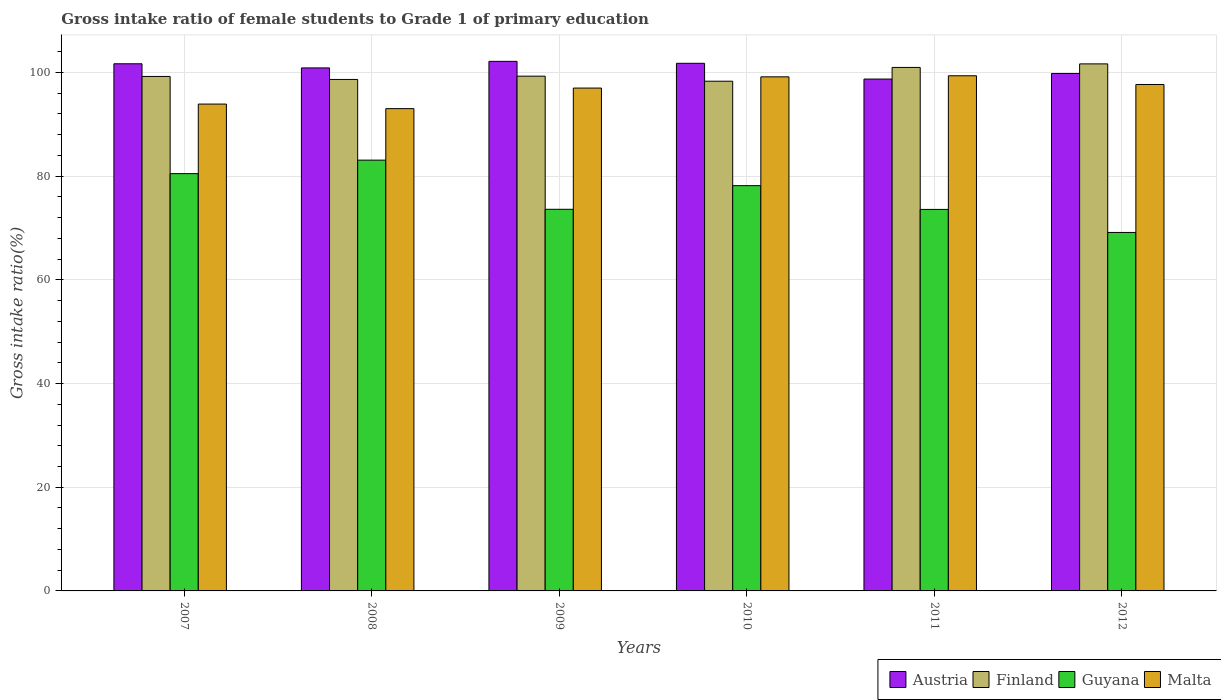Are the number of bars on each tick of the X-axis equal?
Keep it short and to the point. Yes. How many bars are there on the 5th tick from the right?
Your answer should be compact. 4. What is the label of the 6th group of bars from the left?
Ensure brevity in your answer.  2012. In how many cases, is the number of bars for a given year not equal to the number of legend labels?
Your answer should be compact. 0. What is the gross intake ratio in Austria in 2008?
Provide a succinct answer. 100.88. Across all years, what is the maximum gross intake ratio in Guyana?
Your answer should be compact. 83.1. Across all years, what is the minimum gross intake ratio in Guyana?
Your response must be concise. 69.15. In which year was the gross intake ratio in Austria maximum?
Your response must be concise. 2009. In which year was the gross intake ratio in Finland minimum?
Your answer should be very brief. 2010. What is the total gross intake ratio in Malta in the graph?
Offer a terse response. 580.16. What is the difference between the gross intake ratio in Guyana in 2007 and that in 2008?
Provide a succinct answer. -2.61. What is the difference between the gross intake ratio in Guyana in 2011 and the gross intake ratio in Austria in 2008?
Your response must be concise. -27.29. What is the average gross intake ratio in Austria per year?
Ensure brevity in your answer.  100.84. In the year 2007, what is the difference between the gross intake ratio in Malta and gross intake ratio in Finland?
Your answer should be compact. -5.33. In how many years, is the gross intake ratio in Guyana greater than 88 %?
Your answer should be compact. 0. What is the ratio of the gross intake ratio in Finland in 2010 to that in 2012?
Offer a terse response. 0.97. Is the difference between the gross intake ratio in Malta in 2007 and 2011 greater than the difference between the gross intake ratio in Finland in 2007 and 2011?
Keep it short and to the point. No. What is the difference between the highest and the second highest gross intake ratio in Finland?
Keep it short and to the point. 0.68. What is the difference between the highest and the lowest gross intake ratio in Finland?
Provide a succinct answer. 3.34. Is the sum of the gross intake ratio in Guyana in 2008 and 2010 greater than the maximum gross intake ratio in Malta across all years?
Your answer should be compact. Yes. Is it the case that in every year, the sum of the gross intake ratio in Guyana and gross intake ratio in Austria is greater than the sum of gross intake ratio in Finland and gross intake ratio in Malta?
Offer a very short reply. No. What does the 4th bar from the left in 2010 represents?
Offer a very short reply. Malta. What does the 4th bar from the right in 2007 represents?
Offer a very short reply. Austria. How many bars are there?
Your answer should be very brief. 24. Does the graph contain any zero values?
Give a very brief answer. No. Where does the legend appear in the graph?
Offer a very short reply. Bottom right. What is the title of the graph?
Your answer should be very brief. Gross intake ratio of female students to Grade 1 of primary education. What is the label or title of the Y-axis?
Give a very brief answer. Gross intake ratio(%). What is the Gross intake ratio(%) in Austria in 2007?
Provide a succinct answer. 101.68. What is the Gross intake ratio(%) in Finland in 2007?
Provide a short and direct response. 99.24. What is the Gross intake ratio(%) of Guyana in 2007?
Provide a short and direct response. 80.49. What is the Gross intake ratio(%) of Malta in 2007?
Provide a succinct answer. 93.91. What is the Gross intake ratio(%) in Austria in 2008?
Offer a very short reply. 100.88. What is the Gross intake ratio(%) in Finland in 2008?
Provide a short and direct response. 98.66. What is the Gross intake ratio(%) in Guyana in 2008?
Offer a terse response. 83.1. What is the Gross intake ratio(%) in Malta in 2008?
Provide a succinct answer. 93.03. What is the Gross intake ratio(%) of Austria in 2009?
Your response must be concise. 102.15. What is the Gross intake ratio(%) in Finland in 2009?
Make the answer very short. 99.3. What is the Gross intake ratio(%) in Guyana in 2009?
Provide a succinct answer. 73.61. What is the Gross intake ratio(%) in Malta in 2009?
Your response must be concise. 97. What is the Gross intake ratio(%) in Austria in 2010?
Provide a succinct answer. 101.78. What is the Gross intake ratio(%) of Finland in 2010?
Your answer should be compact. 98.32. What is the Gross intake ratio(%) in Guyana in 2010?
Offer a terse response. 78.17. What is the Gross intake ratio(%) in Malta in 2010?
Offer a very short reply. 99.16. What is the Gross intake ratio(%) of Austria in 2011?
Keep it short and to the point. 98.74. What is the Gross intake ratio(%) of Finland in 2011?
Ensure brevity in your answer.  100.98. What is the Gross intake ratio(%) of Guyana in 2011?
Make the answer very short. 73.59. What is the Gross intake ratio(%) of Malta in 2011?
Ensure brevity in your answer.  99.37. What is the Gross intake ratio(%) of Austria in 2012?
Give a very brief answer. 99.81. What is the Gross intake ratio(%) in Finland in 2012?
Offer a very short reply. 101.66. What is the Gross intake ratio(%) in Guyana in 2012?
Give a very brief answer. 69.15. What is the Gross intake ratio(%) in Malta in 2012?
Keep it short and to the point. 97.69. Across all years, what is the maximum Gross intake ratio(%) in Austria?
Offer a very short reply. 102.15. Across all years, what is the maximum Gross intake ratio(%) of Finland?
Your response must be concise. 101.66. Across all years, what is the maximum Gross intake ratio(%) of Guyana?
Your answer should be very brief. 83.1. Across all years, what is the maximum Gross intake ratio(%) in Malta?
Your answer should be very brief. 99.37. Across all years, what is the minimum Gross intake ratio(%) in Austria?
Provide a short and direct response. 98.74. Across all years, what is the minimum Gross intake ratio(%) of Finland?
Give a very brief answer. 98.32. Across all years, what is the minimum Gross intake ratio(%) in Guyana?
Ensure brevity in your answer.  69.15. Across all years, what is the minimum Gross intake ratio(%) in Malta?
Provide a succinct answer. 93.03. What is the total Gross intake ratio(%) in Austria in the graph?
Make the answer very short. 605.04. What is the total Gross intake ratio(%) in Finland in the graph?
Make the answer very short. 598.16. What is the total Gross intake ratio(%) of Guyana in the graph?
Your answer should be very brief. 458.12. What is the total Gross intake ratio(%) of Malta in the graph?
Ensure brevity in your answer.  580.16. What is the difference between the Gross intake ratio(%) of Austria in 2007 and that in 2008?
Provide a succinct answer. 0.8. What is the difference between the Gross intake ratio(%) of Finland in 2007 and that in 2008?
Provide a succinct answer. 0.58. What is the difference between the Gross intake ratio(%) in Guyana in 2007 and that in 2008?
Provide a short and direct response. -2.61. What is the difference between the Gross intake ratio(%) in Malta in 2007 and that in 2008?
Your answer should be very brief. 0.88. What is the difference between the Gross intake ratio(%) of Austria in 2007 and that in 2009?
Your answer should be very brief. -0.47. What is the difference between the Gross intake ratio(%) in Finland in 2007 and that in 2009?
Make the answer very short. -0.06. What is the difference between the Gross intake ratio(%) of Guyana in 2007 and that in 2009?
Give a very brief answer. 6.88. What is the difference between the Gross intake ratio(%) of Malta in 2007 and that in 2009?
Your answer should be compact. -3.09. What is the difference between the Gross intake ratio(%) of Austria in 2007 and that in 2010?
Your answer should be compact. -0.09. What is the difference between the Gross intake ratio(%) of Finland in 2007 and that in 2010?
Provide a short and direct response. 0.92. What is the difference between the Gross intake ratio(%) in Guyana in 2007 and that in 2010?
Offer a terse response. 2.32. What is the difference between the Gross intake ratio(%) of Malta in 2007 and that in 2010?
Offer a very short reply. -5.25. What is the difference between the Gross intake ratio(%) of Austria in 2007 and that in 2011?
Offer a terse response. 2.95. What is the difference between the Gross intake ratio(%) of Finland in 2007 and that in 2011?
Keep it short and to the point. -1.74. What is the difference between the Gross intake ratio(%) of Guyana in 2007 and that in 2011?
Your answer should be very brief. 6.9. What is the difference between the Gross intake ratio(%) in Malta in 2007 and that in 2011?
Your answer should be compact. -5.46. What is the difference between the Gross intake ratio(%) of Austria in 2007 and that in 2012?
Your answer should be very brief. 1.88. What is the difference between the Gross intake ratio(%) in Finland in 2007 and that in 2012?
Your response must be concise. -2.42. What is the difference between the Gross intake ratio(%) in Guyana in 2007 and that in 2012?
Give a very brief answer. 11.34. What is the difference between the Gross intake ratio(%) in Malta in 2007 and that in 2012?
Your response must be concise. -3.77. What is the difference between the Gross intake ratio(%) of Austria in 2008 and that in 2009?
Offer a very short reply. -1.27. What is the difference between the Gross intake ratio(%) of Finland in 2008 and that in 2009?
Your answer should be very brief. -0.63. What is the difference between the Gross intake ratio(%) in Guyana in 2008 and that in 2009?
Your answer should be compact. 9.48. What is the difference between the Gross intake ratio(%) of Malta in 2008 and that in 2009?
Provide a short and direct response. -3.97. What is the difference between the Gross intake ratio(%) in Austria in 2008 and that in 2010?
Offer a terse response. -0.89. What is the difference between the Gross intake ratio(%) in Finland in 2008 and that in 2010?
Ensure brevity in your answer.  0.34. What is the difference between the Gross intake ratio(%) of Guyana in 2008 and that in 2010?
Provide a succinct answer. 4.92. What is the difference between the Gross intake ratio(%) in Malta in 2008 and that in 2010?
Provide a short and direct response. -6.13. What is the difference between the Gross intake ratio(%) of Austria in 2008 and that in 2011?
Keep it short and to the point. 2.15. What is the difference between the Gross intake ratio(%) of Finland in 2008 and that in 2011?
Your answer should be compact. -2.32. What is the difference between the Gross intake ratio(%) in Guyana in 2008 and that in 2011?
Keep it short and to the point. 9.51. What is the difference between the Gross intake ratio(%) in Malta in 2008 and that in 2011?
Provide a succinct answer. -6.34. What is the difference between the Gross intake ratio(%) in Austria in 2008 and that in 2012?
Provide a short and direct response. 1.08. What is the difference between the Gross intake ratio(%) in Finland in 2008 and that in 2012?
Your answer should be very brief. -3. What is the difference between the Gross intake ratio(%) of Guyana in 2008 and that in 2012?
Give a very brief answer. 13.95. What is the difference between the Gross intake ratio(%) in Malta in 2008 and that in 2012?
Your answer should be very brief. -4.65. What is the difference between the Gross intake ratio(%) of Austria in 2009 and that in 2010?
Give a very brief answer. 0.38. What is the difference between the Gross intake ratio(%) of Finland in 2009 and that in 2010?
Ensure brevity in your answer.  0.97. What is the difference between the Gross intake ratio(%) of Guyana in 2009 and that in 2010?
Keep it short and to the point. -4.56. What is the difference between the Gross intake ratio(%) in Malta in 2009 and that in 2010?
Give a very brief answer. -2.17. What is the difference between the Gross intake ratio(%) of Austria in 2009 and that in 2011?
Your answer should be compact. 3.41. What is the difference between the Gross intake ratio(%) in Finland in 2009 and that in 2011?
Offer a terse response. -1.68. What is the difference between the Gross intake ratio(%) in Guyana in 2009 and that in 2011?
Your response must be concise. 0.02. What is the difference between the Gross intake ratio(%) in Malta in 2009 and that in 2011?
Your answer should be compact. -2.37. What is the difference between the Gross intake ratio(%) of Austria in 2009 and that in 2012?
Give a very brief answer. 2.34. What is the difference between the Gross intake ratio(%) of Finland in 2009 and that in 2012?
Provide a succinct answer. -2.37. What is the difference between the Gross intake ratio(%) in Guyana in 2009 and that in 2012?
Your answer should be very brief. 4.47. What is the difference between the Gross intake ratio(%) of Malta in 2009 and that in 2012?
Give a very brief answer. -0.69. What is the difference between the Gross intake ratio(%) of Austria in 2010 and that in 2011?
Offer a terse response. 3.04. What is the difference between the Gross intake ratio(%) in Finland in 2010 and that in 2011?
Give a very brief answer. -2.66. What is the difference between the Gross intake ratio(%) in Guyana in 2010 and that in 2011?
Your answer should be compact. 4.58. What is the difference between the Gross intake ratio(%) of Malta in 2010 and that in 2011?
Your answer should be very brief. -0.2. What is the difference between the Gross intake ratio(%) in Austria in 2010 and that in 2012?
Offer a very short reply. 1.97. What is the difference between the Gross intake ratio(%) of Finland in 2010 and that in 2012?
Provide a succinct answer. -3.34. What is the difference between the Gross intake ratio(%) in Guyana in 2010 and that in 2012?
Offer a very short reply. 9.03. What is the difference between the Gross intake ratio(%) of Malta in 2010 and that in 2012?
Keep it short and to the point. 1.48. What is the difference between the Gross intake ratio(%) of Austria in 2011 and that in 2012?
Provide a succinct answer. -1.07. What is the difference between the Gross intake ratio(%) of Finland in 2011 and that in 2012?
Offer a terse response. -0.68. What is the difference between the Gross intake ratio(%) in Guyana in 2011 and that in 2012?
Your response must be concise. 4.44. What is the difference between the Gross intake ratio(%) of Malta in 2011 and that in 2012?
Make the answer very short. 1.68. What is the difference between the Gross intake ratio(%) in Austria in 2007 and the Gross intake ratio(%) in Finland in 2008?
Your response must be concise. 3.02. What is the difference between the Gross intake ratio(%) in Austria in 2007 and the Gross intake ratio(%) in Guyana in 2008?
Your response must be concise. 18.59. What is the difference between the Gross intake ratio(%) in Austria in 2007 and the Gross intake ratio(%) in Malta in 2008?
Give a very brief answer. 8.65. What is the difference between the Gross intake ratio(%) in Finland in 2007 and the Gross intake ratio(%) in Guyana in 2008?
Your answer should be very brief. 16.14. What is the difference between the Gross intake ratio(%) of Finland in 2007 and the Gross intake ratio(%) of Malta in 2008?
Make the answer very short. 6.21. What is the difference between the Gross intake ratio(%) of Guyana in 2007 and the Gross intake ratio(%) of Malta in 2008?
Your response must be concise. -12.54. What is the difference between the Gross intake ratio(%) of Austria in 2007 and the Gross intake ratio(%) of Finland in 2009?
Keep it short and to the point. 2.39. What is the difference between the Gross intake ratio(%) in Austria in 2007 and the Gross intake ratio(%) in Guyana in 2009?
Keep it short and to the point. 28.07. What is the difference between the Gross intake ratio(%) of Austria in 2007 and the Gross intake ratio(%) of Malta in 2009?
Offer a terse response. 4.69. What is the difference between the Gross intake ratio(%) in Finland in 2007 and the Gross intake ratio(%) in Guyana in 2009?
Keep it short and to the point. 25.63. What is the difference between the Gross intake ratio(%) in Finland in 2007 and the Gross intake ratio(%) in Malta in 2009?
Give a very brief answer. 2.24. What is the difference between the Gross intake ratio(%) of Guyana in 2007 and the Gross intake ratio(%) of Malta in 2009?
Provide a succinct answer. -16.51. What is the difference between the Gross intake ratio(%) of Austria in 2007 and the Gross intake ratio(%) of Finland in 2010?
Provide a succinct answer. 3.36. What is the difference between the Gross intake ratio(%) in Austria in 2007 and the Gross intake ratio(%) in Guyana in 2010?
Your answer should be very brief. 23.51. What is the difference between the Gross intake ratio(%) in Austria in 2007 and the Gross intake ratio(%) in Malta in 2010?
Your answer should be very brief. 2.52. What is the difference between the Gross intake ratio(%) in Finland in 2007 and the Gross intake ratio(%) in Guyana in 2010?
Ensure brevity in your answer.  21.07. What is the difference between the Gross intake ratio(%) in Finland in 2007 and the Gross intake ratio(%) in Malta in 2010?
Give a very brief answer. 0.08. What is the difference between the Gross intake ratio(%) of Guyana in 2007 and the Gross intake ratio(%) of Malta in 2010?
Offer a terse response. -18.67. What is the difference between the Gross intake ratio(%) in Austria in 2007 and the Gross intake ratio(%) in Finland in 2011?
Your response must be concise. 0.7. What is the difference between the Gross intake ratio(%) in Austria in 2007 and the Gross intake ratio(%) in Guyana in 2011?
Your response must be concise. 28.09. What is the difference between the Gross intake ratio(%) in Austria in 2007 and the Gross intake ratio(%) in Malta in 2011?
Make the answer very short. 2.32. What is the difference between the Gross intake ratio(%) of Finland in 2007 and the Gross intake ratio(%) of Guyana in 2011?
Provide a short and direct response. 25.65. What is the difference between the Gross intake ratio(%) in Finland in 2007 and the Gross intake ratio(%) in Malta in 2011?
Offer a terse response. -0.13. What is the difference between the Gross intake ratio(%) of Guyana in 2007 and the Gross intake ratio(%) of Malta in 2011?
Your answer should be compact. -18.88. What is the difference between the Gross intake ratio(%) of Austria in 2007 and the Gross intake ratio(%) of Finland in 2012?
Provide a succinct answer. 0.02. What is the difference between the Gross intake ratio(%) of Austria in 2007 and the Gross intake ratio(%) of Guyana in 2012?
Provide a short and direct response. 32.54. What is the difference between the Gross intake ratio(%) in Austria in 2007 and the Gross intake ratio(%) in Malta in 2012?
Make the answer very short. 4. What is the difference between the Gross intake ratio(%) in Finland in 2007 and the Gross intake ratio(%) in Guyana in 2012?
Provide a short and direct response. 30.09. What is the difference between the Gross intake ratio(%) in Finland in 2007 and the Gross intake ratio(%) in Malta in 2012?
Your answer should be very brief. 1.55. What is the difference between the Gross intake ratio(%) in Guyana in 2007 and the Gross intake ratio(%) in Malta in 2012?
Your response must be concise. -17.19. What is the difference between the Gross intake ratio(%) of Austria in 2008 and the Gross intake ratio(%) of Finland in 2009?
Offer a very short reply. 1.59. What is the difference between the Gross intake ratio(%) in Austria in 2008 and the Gross intake ratio(%) in Guyana in 2009?
Offer a terse response. 27.27. What is the difference between the Gross intake ratio(%) in Austria in 2008 and the Gross intake ratio(%) in Malta in 2009?
Provide a succinct answer. 3.89. What is the difference between the Gross intake ratio(%) in Finland in 2008 and the Gross intake ratio(%) in Guyana in 2009?
Your answer should be very brief. 25.05. What is the difference between the Gross intake ratio(%) of Finland in 2008 and the Gross intake ratio(%) of Malta in 2009?
Offer a very short reply. 1.66. What is the difference between the Gross intake ratio(%) in Guyana in 2008 and the Gross intake ratio(%) in Malta in 2009?
Your response must be concise. -13.9. What is the difference between the Gross intake ratio(%) of Austria in 2008 and the Gross intake ratio(%) of Finland in 2010?
Your response must be concise. 2.56. What is the difference between the Gross intake ratio(%) of Austria in 2008 and the Gross intake ratio(%) of Guyana in 2010?
Your answer should be very brief. 22.71. What is the difference between the Gross intake ratio(%) in Austria in 2008 and the Gross intake ratio(%) in Malta in 2010?
Give a very brief answer. 1.72. What is the difference between the Gross intake ratio(%) of Finland in 2008 and the Gross intake ratio(%) of Guyana in 2010?
Keep it short and to the point. 20.49. What is the difference between the Gross intake ratio(%) in Finland in 2008 and the Gross intake ratio(%) in Malta in 2010?
Your answer should be compact. -0.5. What is the difference between the Gross intake ratio(%) of Guyana in 2008 and the Gross intake ratio(%) of Malta in 2010?
Ensure brevity in your answer.  -16.07. What is the difference between the Gross intake ratio(%) in Austria in 2008 and the Gross intake ratio(%) in Finland in 2011?
Your response must be concise. -0.09. What is the difference between the Gross intake ratio(%) of Austria in 2008 and the Gross intake ratio(%) of Guyana in 2011?
Provide a short and direct response. 27.29. What is the difference between the Gross intake ratio(%) of Austria in 2008 and the Gross intake ratio(%) of Malta in 2011?
Your answer should be very brief. 1.52. What is the difference between the Gross intake ratio(%) of Finland in 2008 and the Gross intake ratio(%) of Guyana in 2011?
Your answer should be very brief. 25.07. What is the difference between the Gross intake ratio(%) in Finland in 2008 and the Gross intake ratio(%) in Malta in 2011?
Offer a terse response. -0.71. What is the difference between the Gross intake ratio(%) of Guyana in 2008 and the Gross intake ratio(%) of Malta in 2011?
Your answer should be compact. -16.27. What is the difference between the Gross intake ratio(%) in Austria in 2008 and the Gross intake ratio(%) in Finland in 2012?
Your answer should be compact. -0.78. What is the difference between the Gross intake ratio(%) of Austria in 2008 and the Gross intake ratio(%) of Guyana in 2012?
Offer a terse response. 31.74. What is the difference between the Gross intake ratio(%) of Austria in 2008 and the Gross intake ratio(%) of Malta in 2012?
Ensure brevity in your answer.  3.2. What is the difference between the Gross intake ratio(%) of Finland in 2008 and the Gross intake ratio(%) of Guyana in 2012?
Your answer should be very brief. 29.51. What is the difference between the Gross intake ratio(%) of Finland in 2008 and the Gross intake ratio(%) of Malta in 2012?
Provide a short and direct response. 0.98. What is the difference between the Gross intake ratio(%) of Guyana in 2008 and the Gross intake ratio(%) of Malta in 2012?
Your answer should be very brief. -14.59. What is the difference between the Gross intake ratio(%) of Austria in 2009 and the Gross intake ratio(%) of Finland in 2010?
Give a very brief answer. 3.83. What is the difference between the Gross intake ratio(%) in Austria in 2009 and the Gross intake ratio(%) in Guyana in 2010?
Your answer should be very brief. 23.98. What is the difference between the Gross intake ratio(%) of Austria in 2009 and the Gross intake ratio(%) of Malta in 2010?
Your response must be concise. 2.99. What is the difference between the Gross intake ratio(%) in Finland in 2009 and the Gross intake ratio(%) in Guyana in 2010?
Offer a terse response. 21.12. What is the difference between the Gross intake ratio(%) in Finland in 2009 and the Gross intake ratio(%) in Malta in 2010?
Your response must be concise. 0.13. What is the difference between the Gross intake ratio(%) in Guyana in 2009 and the Gross intake ratio(%) in Malta in 2010?
Offer a very short reply. -25.55. What is the difference between the Gross intake ratio(%) of Austria in 2009 and the Gross intake ratio(%) of Finland in 2011?
Keep it short and to the point. 1.17. What is the difference between the Gross intake ratio(%) in Austria in 2009 and the Gross intake ratio(%) in Guyana in 2011?
Your answer should be compact. 28.56. What is the difference between the Gross intake ratio(%) of Austria in 2009 and the Gross intake ratio(%) of Malta in 2011?
Offer a terse response. 2.78. What is the difference between the Gross intake ratio(%) in Finland in 2009 and the Gross intake ratio(%) in Guyana in 2011?
Provide a succinct answer. 25.7. What is the difference between the Gross intake ratio(%) of Finland in 2009 and the Gross intake ratio(%) of Malta in 2011?
Your answer should be very brief. -0.07. What is the difference between the Gross intake ratio(%) of Guyana in 2009 and the Gross intake ratio(%) of Malta in 2011?
Your answer should be very brief. -25.75. What is the difference between the Gross intake ratio(%) of Austria in 2009 and the Gross intake ratio(%) of Finland in 2012?
Offer a very short reply. 0.49. What is the difference between the Gross intake ratio(%) in Austria in 2009 and the Gross intake ratio(%) in Guyana in 2012?
Keep it short and to the point. 33. What is the difference between the Gross intake ratio(%) in Austria in 2009 and the Gross intake ratio(%) in Malta in 2012?
Ensure brevity in your answer.  4.46. What is the difference between the Gross intake ratio(%) of Finland in 2009 and the Gross intake ratio(%) of Guyana in 2012?
Provide a short and direct response. 30.15. What is the difference between the Gross intake ratio(%) in Finland in 2009 and the Gross intake ratio(%) in Malta in 2012?
Make the answer very short. 1.61. What is the difference between the Gross intake ratio(%) in Guyana in 2009 and the Gross intake ratio(%) in Malta in 2012?
Provide a short and direct response. -24.07. What is the difference between the Gross intake ratio(%) in Austria in 2010 and the Gross intake ratio(%) in Finland in 2011?
Your answer should be compact. 0.8. What is the difference between the Gross intake ratio(%) in Austria in 2010 and the Gross intake ratio(%) in Guyana in 2011?
Keep it short and to the point. 28.18. What is the difference between the Gross intake ratio(%) of Austria in 2010 and the Gross intake ratio(%) of Malta in 2011?
Make the answer very short. 2.41. What is the difference between the Gross intake ratio(%) in Finland in 2010 and the Gross intake ratio(%) in Guyana in 2011?
Offer a terse response. 24.73. What is the difference between the Gross intake ratio(%) of Finland in 2010 and the Gross intake ratio(%) of Malta in 2011?
Give a very brief answer. -1.05. What is the difference between the Gross intake ratio(%) of Guyana in 2010 and the Gross intake ratio(%) of Malta in 2011?
Offer a terse response. -21.19. What is the difference between the Gross intake ratio(%) of Austria in 2010 and the Gross intake ratio(%) of Finland in 2012?
Provide a short and direct response. 0.11. What is the difference between the Gross intake ratio(%) in Austria in 2010 and the Gross intake ratio(%) in Guyana in 2012?
Make the answer very short. 32.63. What is the difference between the Gross intake ratio(%) of Austria in 2010 and the Gross intake ratio(%) of Malta in 2012?
Ensure brevity in your answer.  4.09. What is the difference between the Gross intake ratio(%) in Finland in 2010 and the Gross intake ratio(%) in Guyana in 2012?
Your response must be concise. 29.17. What is the difference between the Gross intake ratio(%) of Finland in 2010 and the Gross intake ratio(%) of Malta in 2012?
Offer a terse response. 0.63. What is the difference between the Gross intake ratio(%) in Guyana in 2010 and the Gross intake ratio(%) in Malta in 2012?
Give a very brief answer. -19.51. What is the difference between the Gross intake ratio(%) of Austria in 2011 and the Gross intake ratio(%) of Finland in 2012?
Give a very brief answer. -2.93. What is the difference between the Gross intake ratio(%) of Austria in 2011 and the Gross intake ratio(%) of Guyana in 2012?
Make the answer very short. 29.59. What is the difference between the Gross intake ratio(%) in Austria in 2011 and the Gross intake ratio(%) in Malta in 2012?
Keep it short and to the point. 1.05. What is the difference between the Gross intake ratio(%) in Finland in 2011 and the Gross intake ratio(%) in Guyana in 2012?
Ensure brevity in your answer.  31.83. What is the difference between the Gross intake ratio(%) of Finland in 2011 and the Gross intake ratio(%) of Malta in 2012?
Ensure brevity in your answer.  3.29. What is the difference between the Gross intake ratio(%) of Guyana in 2011 and the Gross intake ratio(%) of Malta in 2012?
Your answer should be very brief. -24.09. What is the average Gross intake ratio(%) of Austria per year?
Keep it short and to the point. 100.84. What is the average Gross intake ratio(%) of Finland per year?
Make the answer very short. 99.69. What is the average Gross intake ratio(%) in Guyana per year?
Ensure brevity in your answer.  76.35. What is the average Gross intake ratio(%) in Malta per year?
Offer a terse response. 96.69. In the year 2007, what is the difference between the Gross intake ratio(%) of Austria and Gross intake ratio(%) of Finland?
Offer a terse response. 2.44. In the year 2007, what is the difference between the Gross intake ratio(%) in Austria and Gross intake ratio(%) in Guyana?
Ensure brevity in your answer.  21.19. In the year 2007, what is the difference between the Gross intake ratio(%) in Austria and Gross intake ratio(%) in Malta?
Your answer should be compact. 7.77. In the year 2007, what is the difference between the Gross intake ratio(%) in Finland and Gross intake ratio(%) in Guyana?
Keep it short and to the point. 18.75. In the year 2007, what is the difference between the Gross intake ratio(%) of Finland and Gross intake ratio(%) of Malta?
Keep it short and to the point. 5.33. In the year 2007, what is the difference between the Gross intake ratio(%) of Guyana and Gross intake ratio(%) of Malta?
Give a very brief answer. -13.42. In the year 2008, what is the difference between the Gross intake ratio(%) of Austria and Gross intake ratio(%) of Finland?
Offer a very short reply. 2.22. In the year 2008, what is the difference between the Gross intake ratio(%) of Austria and Gross intake ratio(%) of Guyana?
Your answer should be very brief. 17.79. In the year 2008, what is the difference between the Gross intake ratio(%) in Austria and Gross intake ratio(%) in Malta?
Your response must be concise. 7.85. In the year 2008, what is the difference between the Gross intake ratio(%) of Finland and Gross intake ratio(%) of Guyana?
Offer a very short reply. 15.57. In the year 2008, what is the difference between the Gross intake ratio(%) in Finland and Gross intake ratio(%) in Malta?
Keep it short and to the point. 5.63. In the year 2008, what is the difference between the Gross intake ratio(%) in Guyana and Gross intake ratio(%) in Malta?
Give a very brief answer. -9.94. In the year 2009, what is the difference between the Gross intake ratio(%) in Austria and Gross intake ratio(%) in Finland?
Offer a terse response. 2.86. In the year 2009, what is the difference between the Gross intake ratio(%) of Austria and Gross intake ratio(%) of Guyana?
Ensure brevity in your answer.  28.54. In the year 2009, what is the difference between the Gross intake ratio(%) in Austria and Gross intake ratio(%) in Malta?
Provide a short and direct response. 5.15. In the year 2009, what is the difference between the Gross intake ratio(%) in Finland and Gross intake ratio(%) in Guyana?
Offer a very short reply. 25.68. In the year 2009, what is the difference between the Gross intake ratio(%) in Finland and Gross intake ratio(%) in Malta?
Your response must be concise. 2.3. In the year 2009, what is the difference between the Gross intake ratio(%) in Guyana and Gross intake ratio(%) in Malta?
Your answer should be very brief. -23.38. In the year 2010, what is the difference between the Gross intake ratio(%) in Austria and Gross intake ratio(%) in Finland?
Keep it short and to the point. 3.45. In the year 2010, what is the difference between the Gross intake ratio(%) in Austria and Gross intake ratio(%) in Guyana?
Provide a succinct answer. 23.6. In the year 2010, what is the difference between the Gross intake ratio(%) of Austria and Gross intake ratio(%) of Malta?
Offer a very short reply. 2.61. In the year 2010, what is the difference between the Gross intake ratio(%) of Finland and Gross intake ratio(%) of Guyana?
Make the answer very short. 20.15. In the year 2010, what is the difference between the Gross intake ratio(%) of Finland and Gross intake ratio(%) of Malta?
Your answer should be very brief. -0.84. In the year 2010, what is the difference between the Gross intake ratio(%) of Guyana and Gross intake ratio(%) of Malta?
Your answer should be compact. -20.99. In the year 2011, what is the difference between the Gross intake ratio(%) of Austria and Gross intake ratio(%) of Finland?
Make the answer very short. -2.24. In the year 2011, what is the difference between the Gross intake ratio(%) of Austria and Gross intake ratio(%) of Guyana?
Give a very brief answer. 25.15. In the year 2011, what is the difference between the Gross intake ratio(%) of Austria and Gross intake ratio(%) of Malta?
Your answer should be very brief. -0.63. In the year 2011, what is the difference between the Gross intake ratio(%) of Finland and Gross intake ratio(%) of Guyana?
Provide a short and direct response. 27.39. In the year 2011, what is the difference between the Gross intake ratio(%) in Finland and Gross intake ratio(%) in Malta?
Give a very brief answer. 1.61. In the year 2011, what is the difference between the Gross intake ratio(%) in Guyana and Gross intake ratio(%) in Malta?
Keep it short and to the point. -25.78. In the year 2012, what is the difference between the Gross intake ratio(%) in Austria and Gross intake ratio(%) in Finland?
Ensure brevity in your answer.  -1.85. In the year 2012, what is the difference between the Gross intake ratio(%) of Austria and Gross intake ratio(%) of Guyana?
Your answer should be compact. 30.66. In the year 2012, what is the difference between the Gross intake ratio(%) of Austria and Gross intake ratio(%) of Malta?
Keep it short and to the point. 2.12. In the year 2012, what is the difference between the Gross intake ratio(%) of Finland and Gross intake ratio(%) of Guyana?
Provide a short and direct response. 32.52. In the year 2012, what is the difference between the Gross intake ratio(%) of Finland and Gross intake ratio(%) of Malta?
Give a very brief answer. 3.98. In the year 2012, what is the difference between the Gross intake ratio(%) in Guyana and Gross intake ratio(%) in Malta?
Keep it short and to the point. -28.54. What is the ratio of the Gross intake ratio(%) of Austria in 2007 to that in 2008?
Your response must be concise. 1.01. What is the ratio of the Gross intake ratio(%) in Finland in 2007 to that in 2008?
Give a very brief answer. 1.01. What is the ratio of the Gross intake ratio(%) of Guyana in 2007 to that in 2008?
Make the answer very short. 0.97. What is the ratio of the Gross intake ratio(%) in Malta in 2007 to that in 2008?
Offer a terse response. 1.01. What is the ratio of the Gross intake ratio(%) of Austria in 2007 to that in 2009?
Your answer should be very brief. 1. What is the ratio of the Gross intake ratio(%) in Finland in 2007 to that in 2009?
Your response must be concise. 1. What is the ratio of the Gross intake ratio(%) in Guyana in 2007 to that in 2009?
Your response must be concise. 1.09. What is the ratio of the Gross intake ratio(%) in Malta in 2007 to that in 2009?
Give a very brief answer. 0.97. What is the ratio of the Gross intake ratio(%) in Finland in 2007 to that in 2010?
Give a very brief answer. 1.01. What is the ratio of the Gross intake ratio(%) of Guyana in 2007 to that in 2010?
Offer a very short reply. 1.03. What is the ratio of the Gross intake ratio(%) of Malta in 2007 to that in 2010?
Your answer should be compact. 0.95. What is the ratio of the Gross intake ratio(%) in Austria in 2007 to that in 2011?
Ensure brevity in your answer.  1.03. What is the ratio of the Gross intake ratio(%) in Finland in 2007 to that in 2011?
Make the answer very short. 0.98. What is the ratio of the Gross intake ratio(%) in Guyana in 2007 to that in 2011?
Your answer should be very brief. 1.09. What is the ratio of the Gross intake ratio(%) of Malta in 2007 to that in 2011?
Your answer should be very brief. 0.95. What is the ratio of the Gross intake ratio(%) in Austria in 2007 to that in 2012?
Your answer should be compact. 1.02. What is the ratio of the Gross intake ratio(%) of Finland in 2007 to that in 2012?
Ensure brevity in your answer.  0.98. What is the ratio of the Gross intake ratio(%) of Guyana in 2007 to that in 2012?
Your answer should be very brief. 1.16. What is the ratio of the Gross intake ratio(%) in Malta in 2007 to that in 2012?
Ensure brevity in your answer.  0.96. What is the ratio of the Gross intake ratio(%) of Austria in 2008 to that in 2009?
Offer a very short reply. 0.99. What is the ratio of the Gross intake ratio(%) of Guyana in 2008 to that in 2009?
Keep it short and to the point. 1.13. What is the ratio of the Gross intake ratio(%) of Malta in 2008 to that in 2009?
Make the answer very short. 0.96. What is the ratio of the Gross intake ratio(%) of Guyana in 2008 to that in 2010?
Offer a terse response. 1.06. What is the ratio of the Gross intake ratio(%) in Malta in 2008 to that in 2010?
Keep it short and to the point. 0.94. What is the ratio of the Gross intake ratio(%) in Austria in 2008 to that in 2011?
Your answer should be compact. 1.02. What is the ratio of the Gross intake ratio(%) of Finland in 2008 to that in 2011?
Your answer should be compact. 0.98. What is the ratio of the Gross intake ratio(%) of Guyana in 2008 to that in 2011?
Your response must be concise. 1.13. What is the ratio of the Gross intake ratio(%) in Malta in 2008 to that in 2011?
Keep it short and to the point. 0.94. What is the ratio of the Gross intake ratio(%) in Austria in 2008 to that in 2012?
Offer a very short reply. 1.01. What is the ratio of the Gross intake ratio(%) of Finland in 2008 to that in 2012?
Your answer should be compact. 0.97. What is the ratio of the Gross intake ratio(%) of Guyana in 2008 to that in 2012?
Offer a very short reply. 1.2. What is the ratio of the Gross intake ratio(%) of Malta in 2008 to that in 2012?
Provide a succinct answer. 0.95. What is the ratio of the Gross intake ratio(%) of Finland in 2009 to that in 2010?
Give a very brief answer. 1.01. What is the ratio of the Gross intake ratio(%) in Guyana in 2009 to that in 2010?
Provide a short and direct response. 0.94. What is the ratio of the Gross intake ratio(%) of Malta in 2009 to that in 2010?
Keep it short and to the point. 0.98. What is the ratio of the Gross intake ratio(%) of Austria in 2009 to that in 2011?
Offer a terse response. 1.03. What is the ratio of the Gross intake ratio(%) of Finland in 2009 to that in 2011?
Keep it short and to the point. 0.98. What is the ratio of the Gross intake ratio(%) in Malta in 2009 to that in 2011?
Ensure brevity in your answer.  0.98. What is the ratio of the Gross intake ratio(%) in Austria in 2009 to that in 2012?
Ensure brevity in your answer.  1.02. What is the ratio of the Gross intake ratio(%) of Finland in 2009 to that in 2012?
Make the answer very short. 0.98. What is the ratio of the Gross intake ratio(%) in Guyana in 2009 to that in 2012?
Offer a very short reply. 1.06. What is the ratio of the Gross intake ratio(%) of Malta in 2009 to that in 2012?
Make the answer very short. 0.99. What is the ratio of the Gross intake ratio(%) in Austria in 2010 to that in 2011?
Provide a succinct answer. 1.03. What is the ratio of the Gross intake ratio(%) in Finland in 2010 to that in 2011?
Your answer should be very brief. 0.97. What is the ratio of the Gross intake ratio(%) of Guyana in 2010 to that in 2011?
Your answer should be very brief. 1.06. What is the ratio of the Gross intake ratio(%) in Austria in 2010 to that in 2012?
Provide a short and direct response. 1.02. What is the ratio of the Gross intake ratio(%) in Finland in 2010 to that in 2012?
Give a very brief answer. 0.97. What is the ratio of the Gross intake ratio(%) in Guyana in 2010 to that in 2012?
Your response must be concise. 1.13. What is the ratio of the Gross intake ratio(%) of Malta in 2010 to that in 2012?
Provide a short and direct response. 1.02. What is the ratio of the Gross intake ratio(%) in Austria in 2011 to that in 2012?
Provide a short and direct response. 0.99. What is the ratio of the Gross intake ratio(%) in Finland in 2011 to that in 2012?
Provide a short and direct response. 0.99. What is the ratio of the Gross intake ratio(%) of Guyana in 2011 to that in 2012?
Provide a succinct answer. 1.06. What is the ratio of the Gross intake ratio(%) in Malta in 2011 to that in 2012?
Your answer should be compact. 1.02. What is the difference between the highest and the second highest Gross intake ratio(%) of Austria?
Ensure brevity in your answer.  0.38. What is the difference between the highest and the second highest Gross intake ratio(%) of Finland?
Keep it short and to the point. 0.68. What is the difference between the highest and the second highest Gross intake ratio(%) of Guyana?
Provide a succinct answer. 2.61. What is the difference between the highest and the second highest Gross intake ratio(%) of Malta?
Your answer should be very brief. 0.2. What is the difference between the highest and the lowest Gross intake ratio(%) of Austria?
Keep it short and to the point. 3.41. What is the difference between the highest and the lowest Gross intake ratio(%) in Finland?
Make the answer very short. 3.34. What is the difference between the highest and the lowest Gross intake ratio(%) in Guyana?
Give a very brief answer. 13.95. What is the difference between the highest and the lowest Gross intake ratio(%) of Malta?
Offer a terse response. 6.34. 